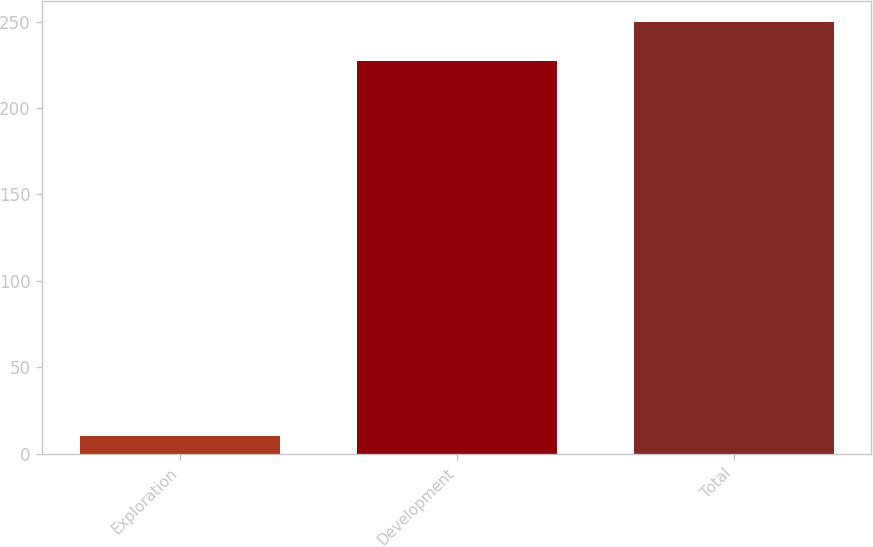Convert chart to OTSL. <chart><loc_0><loc_0><loc_500><loc_500><bar_chart><fcel>Exploration<fcel>Development<fcel>Total<nl><fcel>10<fcel>227<fcel>249.7<nl></chart> 